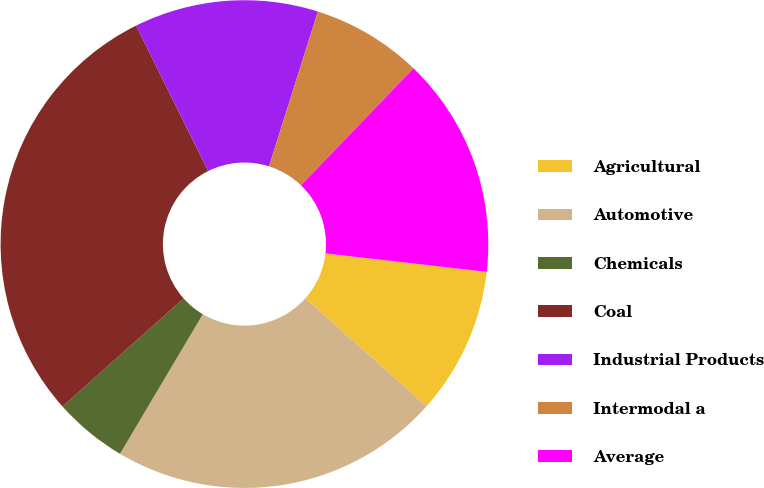<chart> <loc_0><loc_0><loc_500><loc_500><pie_chart><fcel>Agricultural<fcel>Automotive<fcel>Chemicals<fcel>Coal<fcel>Industrial Products<fcel>Intermodal a<fcel>Average<nl><fcel>9.76%<fcel>21.95%<fcel>4.88%<fcel>29.27%<fcel>12.2%<fcel>7.32%<fcel>14.63%<nl></chart> 